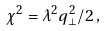Convert formula to latex. <formula><loc_0><loc_0><loc_500><loc_500>\chi ^ { 2 } = \lambda ^ { 2 } q _ { \bot } ^ { 2 } / 2 \, ,</formula> 